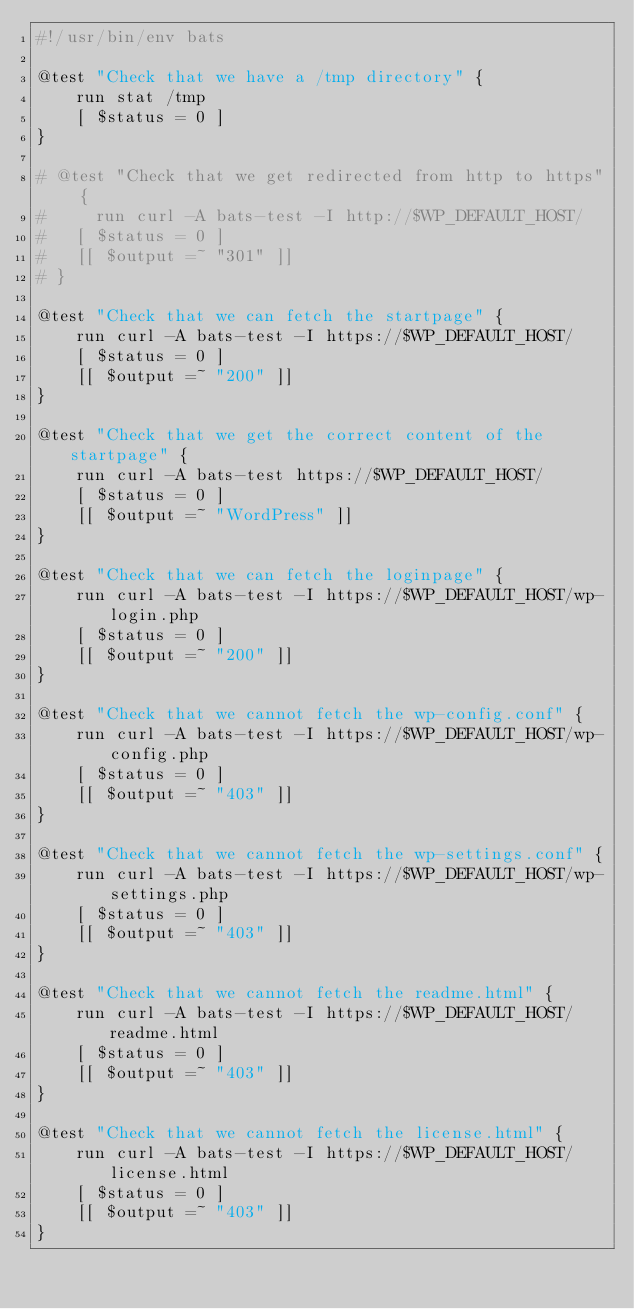<code> <loc_0><loc_0><loc_500><loc_500><_Bash_>#!/usr/bin/env bats

@test "Check that we have a /tmp directory" {
    run stat /tmp
    [ $status = 0 ]
}

# @test "Check that we get redirected from http to https" {
#     run curl -A bats-test -I http://$WP_DEFAULT_HOST/
# 	[ $status = 0 ]
# 	[[ $output =~ "301" ]]
# }

@test "Check that we can fetch the startpage" {
    run curl -A bats-test -I https://$WP_DEFAULT_HOST/
    [ $status = 0 ]
    [[ $output =~ "200" ]]
}

@test "Check that we get the correct content of the startpage" {
    run curl -A bats-test https://$WP_DEFAULT_HOST/
    [ $status = 0 ]
    [[ $output =~ "WordPress" ]]
}

@test "Check that we can fetch the loginpage" {
    run curl -A bats-test -I https://$WP_DEFAULT_HOST/wp-login.php
    [ $status = 0 ]
    [[ $output =~ "200" ]]
}

@test "Check that we cannot fetch the wp-config.conf" {
    run curl -A bats-test -I https://$WP_DEFAULT_HOST/wp-config.php
    [ $status = 0 ]
    [[ $output =~ "403" ]]
}

@test "Check that we cannot fetch the wp-settings.conf" {
    run curl -A bats-test -I https://$WP_DEFAULT_HOST/wp-settings.php
    [ $status = 0 ]
    [[ $output =~ "403" ]]
}

@test "Check that we cannot fetch the readme.html" {
    run curl -A bats-test -I https://$WP_DEFAULT_HOST/readme.html
    [ $status = 0 ]
    [[ $output =~ "403" ]]
}

@test "Check that we cannot fetch the license.html" {
    run curl -A bats-test -I https://$WP_DEFAULT_HOST/license.html
    [ $status = 0 ]
    [[ $output =~ "403" ]]
}
</code> 